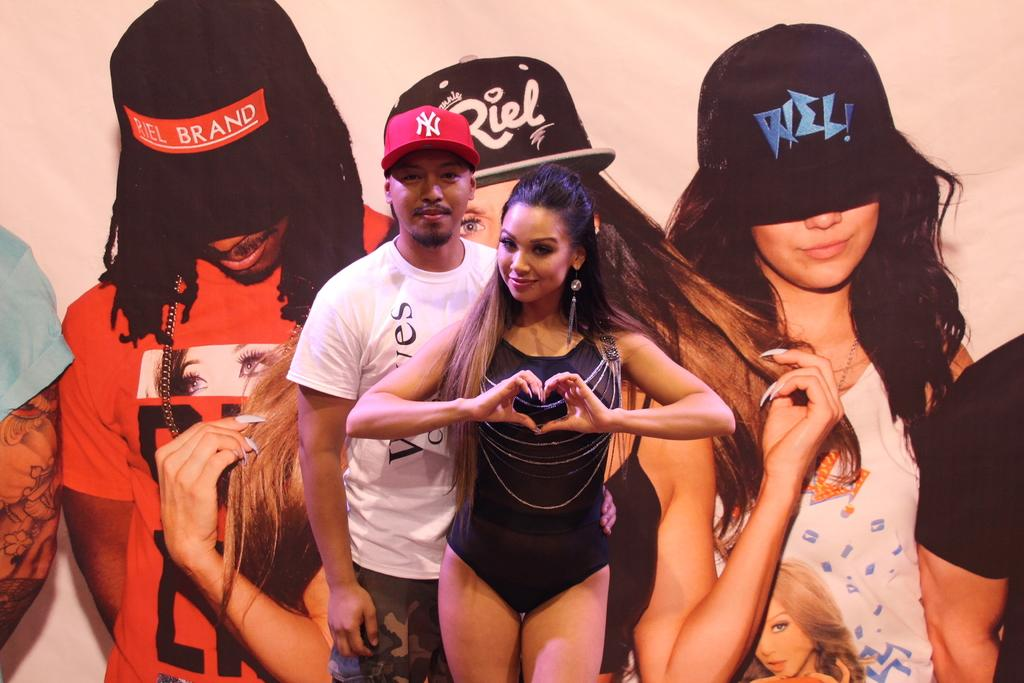<image>
Provide a brief description of the given image. a man wearing a NY hat standing next to a young woman 